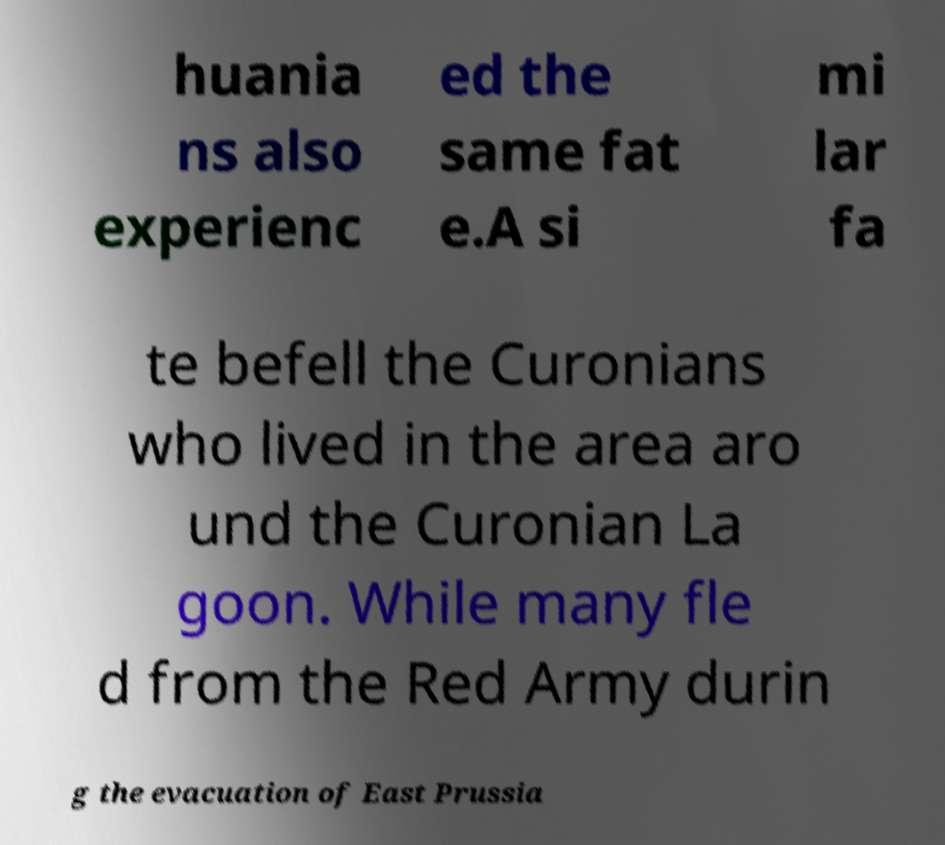Please read and relay the text visible in this image. What does it say? huania ns also experienc ed the same fat e.A si mi lar fa te befell the Curonians who lived in the area aro und the Curonian La goon. While many fle d from the Red Army durin g the evacuation of East Prussia 